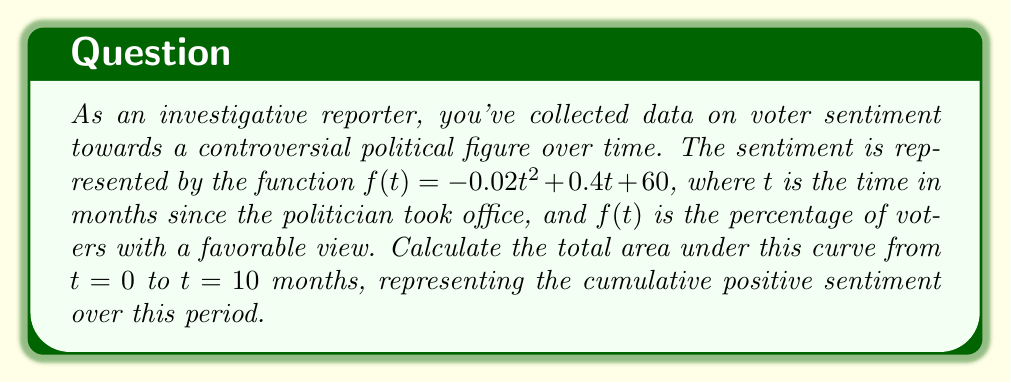Solve this math problem. To calculate the area under the curve, we need to integrate the function $f(t)$ from $t=0$ to $t=10$. Let's follow these steps:

1) The integral we need to evaluate is:

   $$\int_0^{10} (-0.02t^2 + 0.4t + 60) dt$$

2) Integrate each term separately:
   
   $$\int -0.02t^2 dt = -\frac{0.02t^3}{3}$$
   $$\int 0.4t dt = 0.2t^2$$
   $$\int 60 dt = 60t$$

3) Combine these results:

   $$\int (-0.02t^2 + 0.4t + 60) dt = -\frac{0.02t^3}{3} + 0.2t^2 + 60t + C$$

4) Now, we need to evaluate this from 0 to 10:

   $$[-\frac{0.02t^3}{3} + 0.2t^2 + 60t]_0^{10}$$

5) Substitute $t=10$ and $t=0$:

   $$(-\frac{0.02(10)^3}{3} + 0.2(10)^2 + 60(10)) - (-\frac{0.02(0)^3}{3} + 0.2(0)^2 + 60(0))$$

6) Simplify:

   $$(-\frac{20}{3} + 20 + 600) - (0)$$

   $$= \frac{-20 + 60 + 1800}{3}$$

   $$= \frac{1840}{3}$$

   $$\approx 613.33$$

The area represents the cumulative positive sentiment over 10 months, measured in percentage-months.
Answer: 613.33 percentage-months 